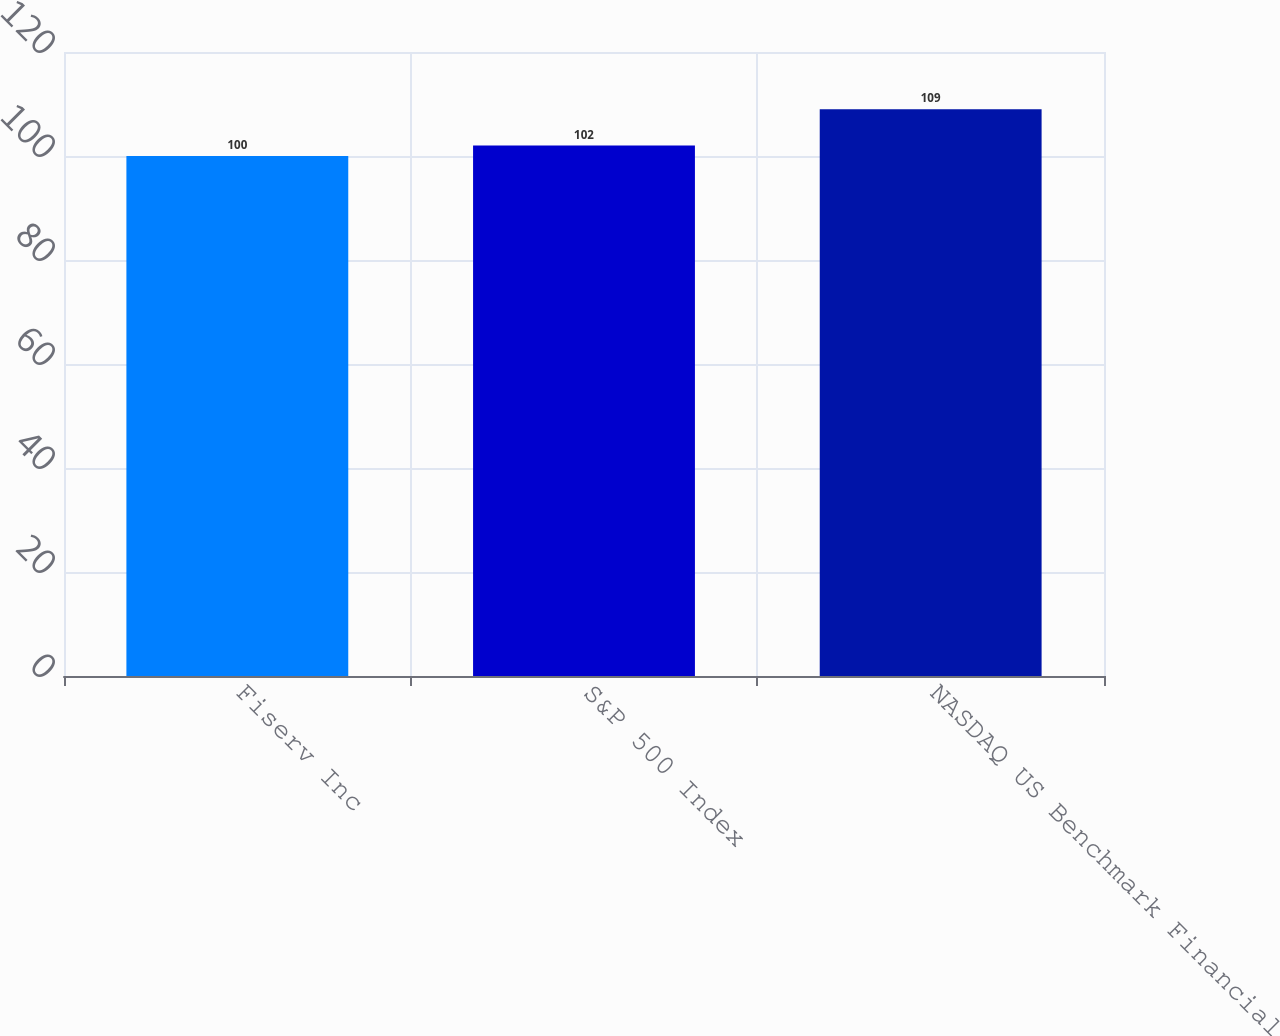<chart> <loc_0><loc_0><loc_500><loc_500><bar_chart><fcel>Fiserv Inc<fcel>S&P 500 Index<fcel>NASDAQ US Benchmark Financial<nl><fcel>100<fcel>102<fcel>109<nl></chart> 